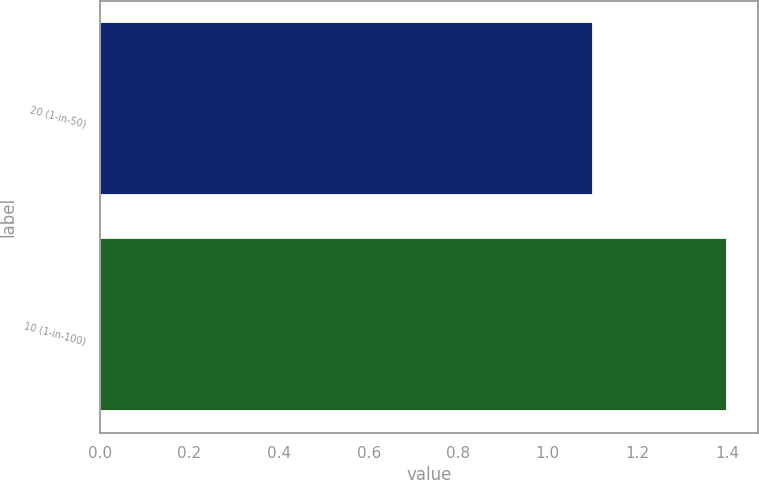Convert chart to OTSL. <chart><loc_0><loc_0><loc_500><loc_500><bar_chart><fcel>20 (1-in-50)<fcel>10 (1-in-100)<nl><fcel>1.1<fcel>1.4<nl></chart> 